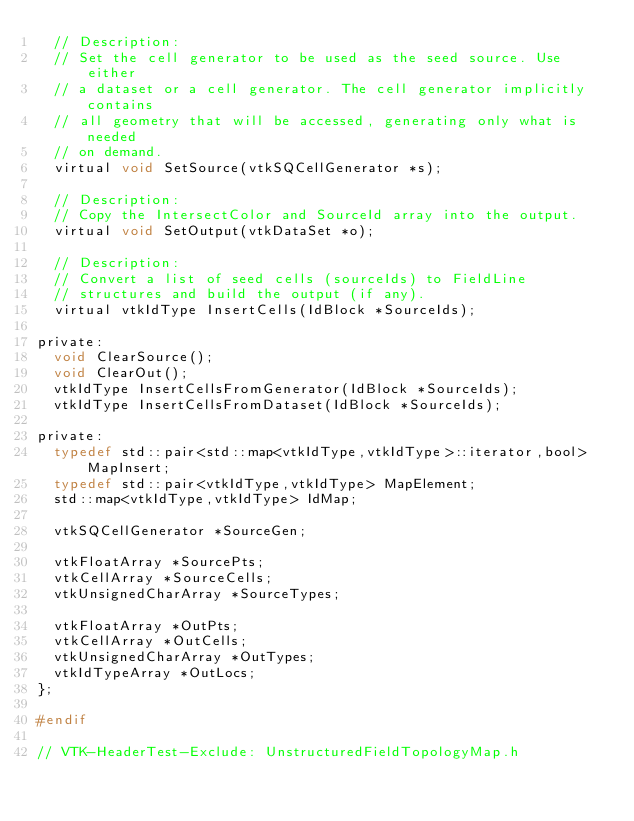Convert code to text. <code><loc_0><loc_0><loc_500><loc_500><_C_>  // Description:
  // Set the cell generator to be used as the seed source. Use either
  // a dataset or a cell generator. The cell generator implicitly contains
  // all geometry that will be accessed, generating only what is needed
  // on demand.
  virtual void SetSource(vtkSQCellGenerator *s);

  // Description:
  // Copy the IntersectColor and SourceId array into the output.
  virtual void SetOutput(vtkDataSet *o);

  // Description:
  // Convert a list of seed cells (sourceIds) to FieldLine
  // structures and build the output (if any).
  virtual vtkIdType InsertCells(IdBlock *SourceIds);

private:
  void ClearSource();
  void ClearOut();
  vtkIdType InsertCellsFromGenerator(IdBlock *SourceIds);
  vtkIdType InsertCellsFromDataset(IdBlock *SourceIds);

private:
  typedef std::pair<std::map<vtkIdType,vtkIdType>::iterator,bool> MapInsert;
  typedef std::pair<vtkIdType,vtkIdType> MapElement;
  std::map<vtkIdType,vtkIdType> IdMap;

  vtkSQCellGenerator *SourceGen;

  vtkFloatArray *SourcePts;
  vtkCellArray *SourceCells;
  vtkUnsignedCharArray *SourceTypes;

  vtkFloatArray *OutPts;
  vtkCellArray *OutCells;
  vtkUnsignedCharArray *OutTypes;
  vtkIdTypeArray *OutLocs;
};

#endif

// VTK-HeaderTest-Exclude: UnstructuredFieldTopologyMap.h
</code> 